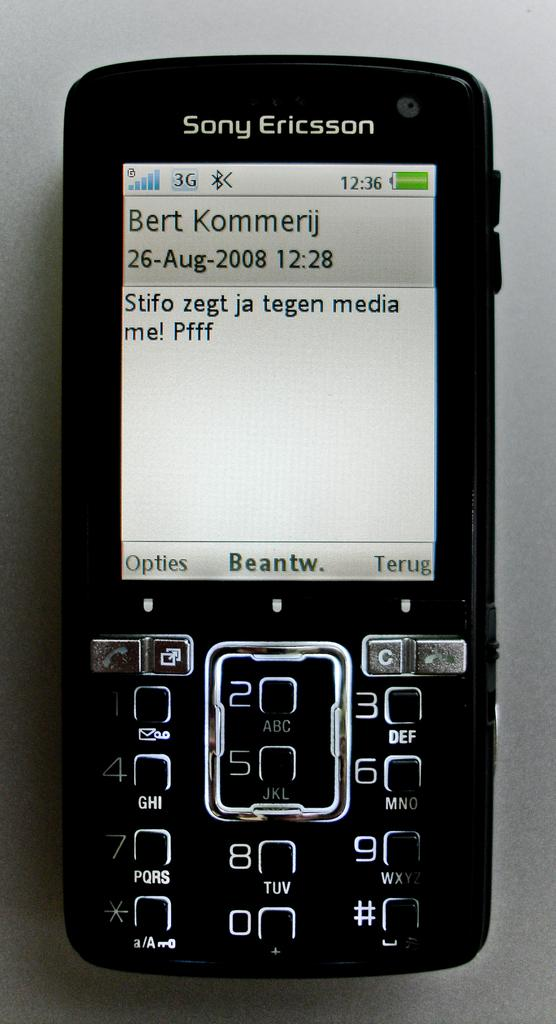<image>
Provide a brief description of the given image. a Sony Ericsson phone that is somewhat old fashioned. 